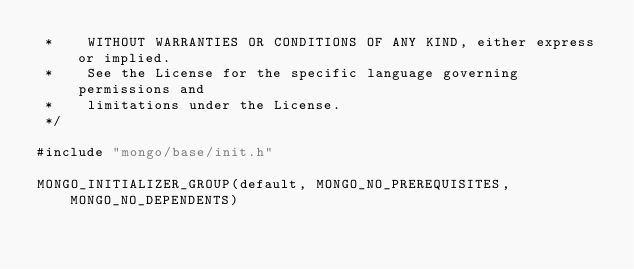Convert code to text. <code><loc_0><loc_0><loc_500><loc_500><_C++_> *    WITHOUT WARRANTIES OR CONDITIONS OF ANY KIND, either express or implied.
 *    See the License for the specific language governing permissions and
 *    limitations under the License.
 */

#include "mongo/base/init.h"

MONGO_INITIALIZER_GROUP(default, MONGO_NO_PREREQUISITES, MONGO_NO_DEPENDENTS)
</code> 